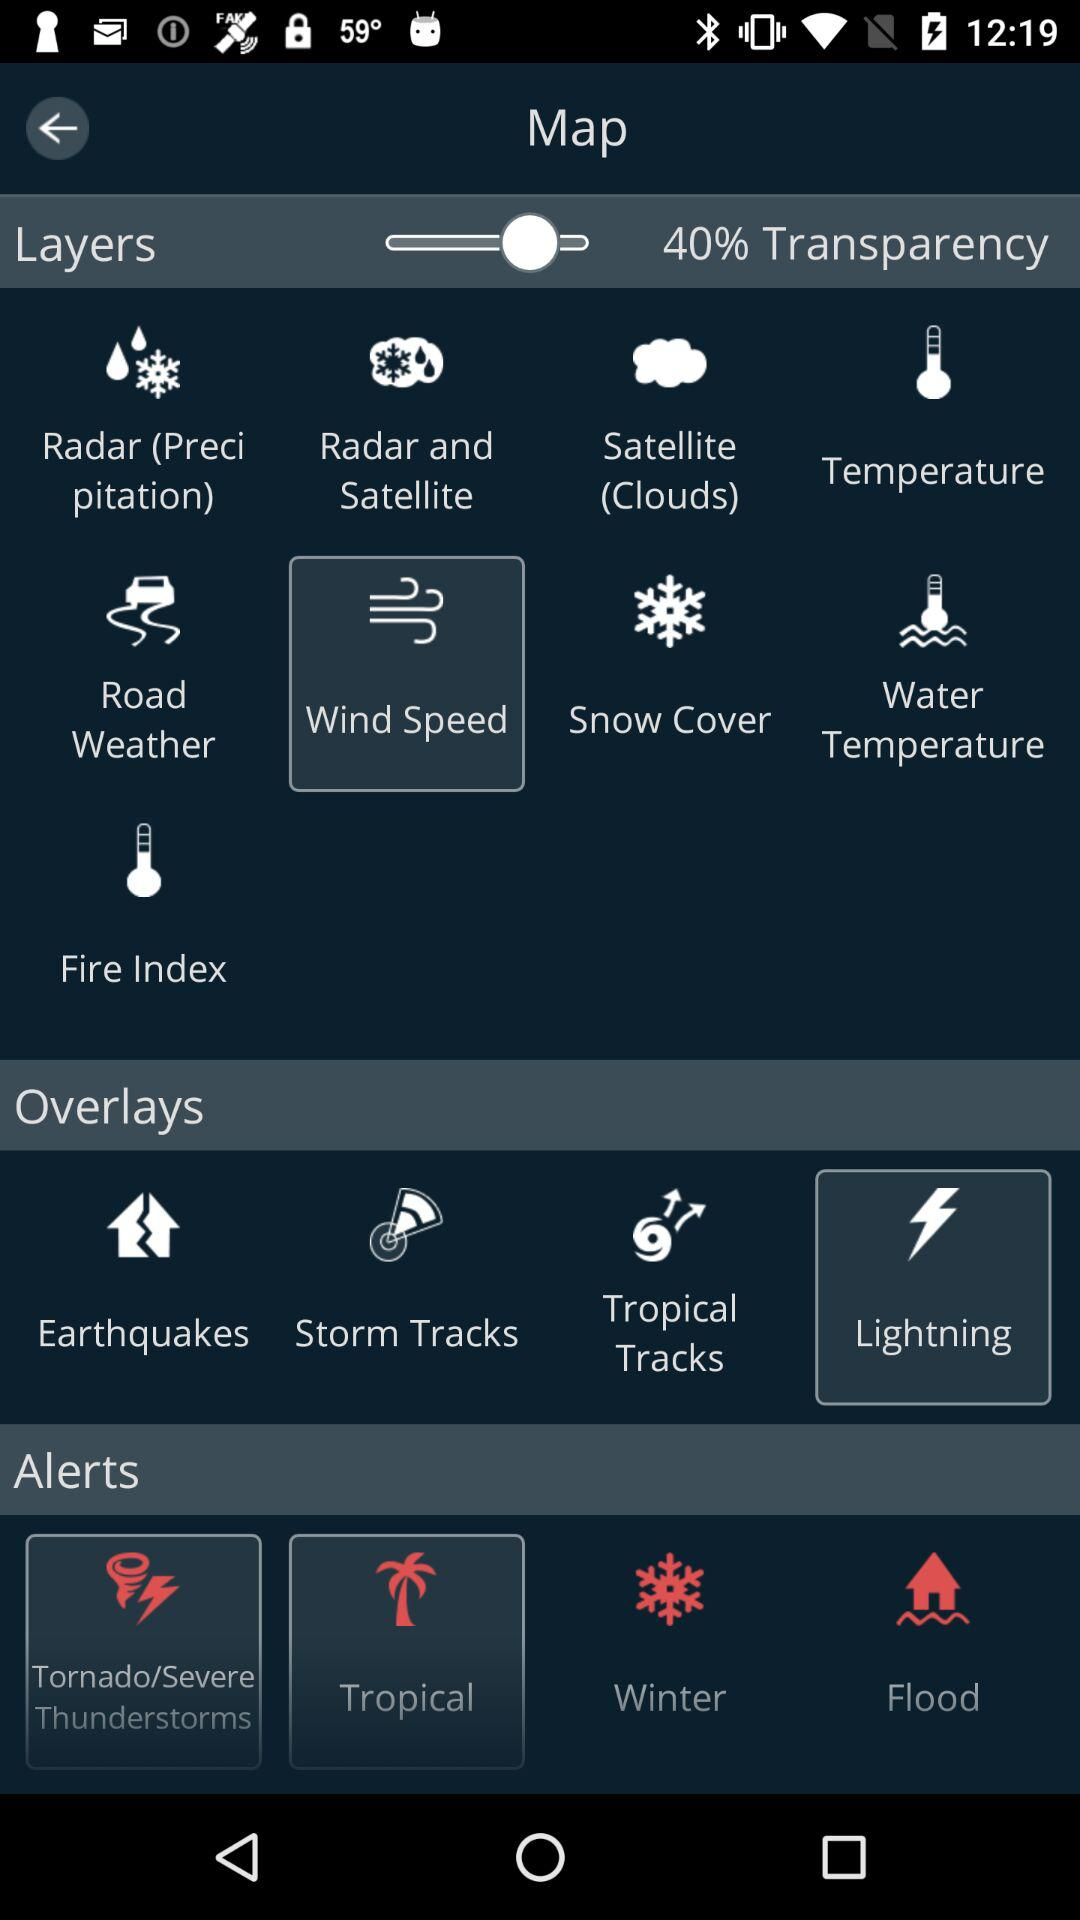Which option is selected in "Overlays"? The selected option is "Lightning". 